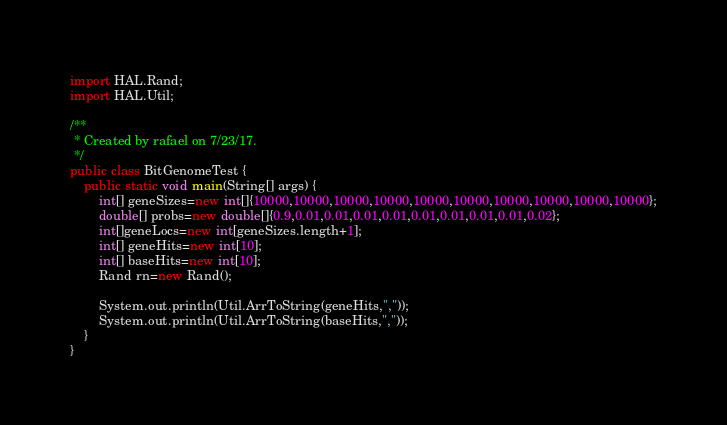Convert code to text. <code><loc_0><loc_0><loc_500><loc_500><_Java_>import HAL.Rand;
import HAL.Util;

/**
 * Created by rafael on 7/23/17.
 */
public class BitGenomeTest {
    public static void main(String[] args) {
        int[] geneSizes=new int[]{10000,10000,10000,10000,10000,10000,10000,10000,10000,10000};
        double[] probs=new double[]{0.9,0.01,0.01,0.01,0.01,0.01,0.01,0.01,0.01,0.02};
        int[]geneLocs=new int[geneSizes.length+1];
        int[] geneHits=new int[10];
        int[] baseHits=new int[10];
        Rand rn=new Rand();

        System.out.println(Util.ArrToString(geneHits,","));
        System.out.println(Util.ArrToString(baseHits,","));
    }
}
</code> 